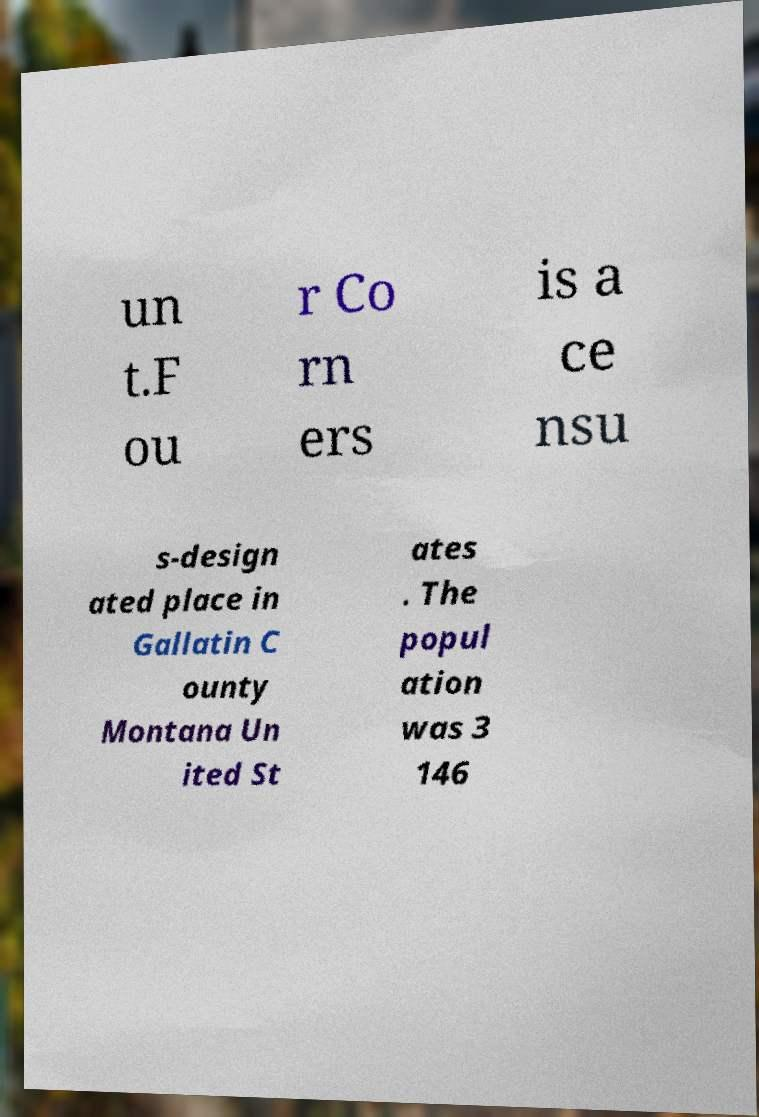Could you extract and type out the text from this image? un t.F ou r Co rn ers is a ce nsu s-design ated place in Gallatin C ounty Montana Un ited St ates . The popul ation was 3 146 